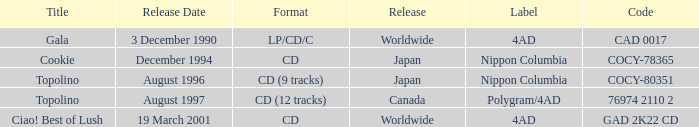When was Gala released? Worldwide. 